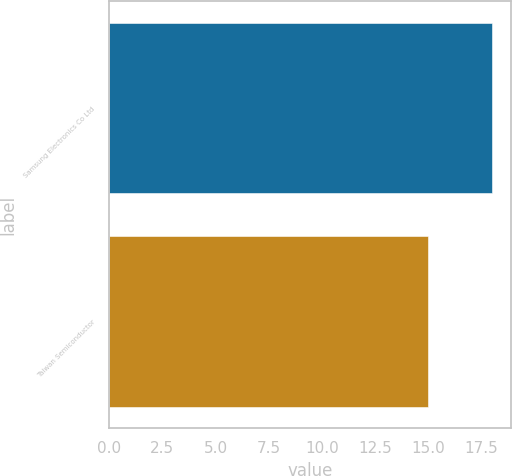Convert chart to OTSL. <chart><loc_0><loc_0><loc_500><loc_500><bar_chart><fcel>Samsung Electronics Co Ltd<fcel>Taiwan Semiconductor<nl><fcel>18<fcel>15<nl></chart> 